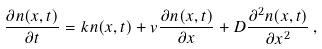Convert formula to latex. <formula><loc_0><loc_0><loc_500><loc_500>\frac { \partial n ( x , t ) } { \partial t } = k n ( x , t ) + v \frac { \partial n ( x , t ) } { \partial x } + D \frac { \partial ^ { 2 } n ( x , t ) } { \partial x ^ { 2 } } \, ,</formula> 